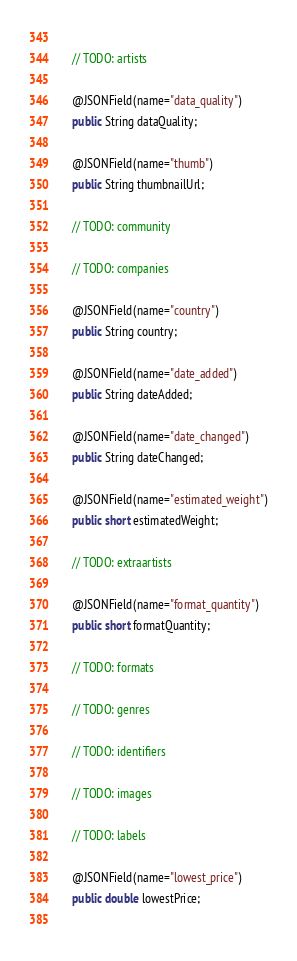Convert code to text. <code><loc_0><loc_0><loc_500><loc_500><_Java_>	
	// TODO: artists
	
	@JSONField(name="data_quality")
	public String dataQuality;
	
	@JSONField(name="thumb")
	public String thumbnailUrl;
	
	// TODO: community
	
	// TODO: companies
	
	@JSONField(name="country")
	public String country;
	
	@JSONField(name="date_added")
	public String dateAdded;
	
	@JSONField(name="date_changed")
	public String dateChanged;
	
	@JSONField(name="estimated_weight")
	public short estimatedWeight;
	
	// TODO: extraartists
	
	@JSONField(name="format_quantity")
	public short formatQuantity;
	
	// TODO: formats
	
	// TODO: genres
	
	// TODO: identifiers
	
	// TODO: images
	
	// TODO: labels
	
	@JSONField(name="lowest_price")
	public double lowestPrice;
	</code> 